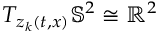<formula> <loc_0><loc_0><loc_500><loc_500>T _ { z _ { k } ( t , x ) } \mathbb { S } ^ { 2 } \cong \mathbb { R } ^ { 2 }</formula> 